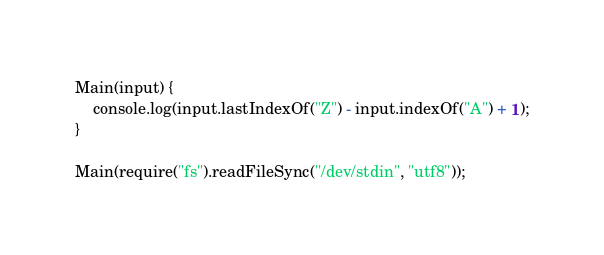Convert code to text. <code><loc_0><loc_0><loc_500><loc_500><_TypeScript_>Main(input) {
	console.log(input.lastIndexOf("Z") - input.indexOf("A") + 1);
}

Main(require("fs").readFileSync("/dev/stdin", "utf8"));
</code> 